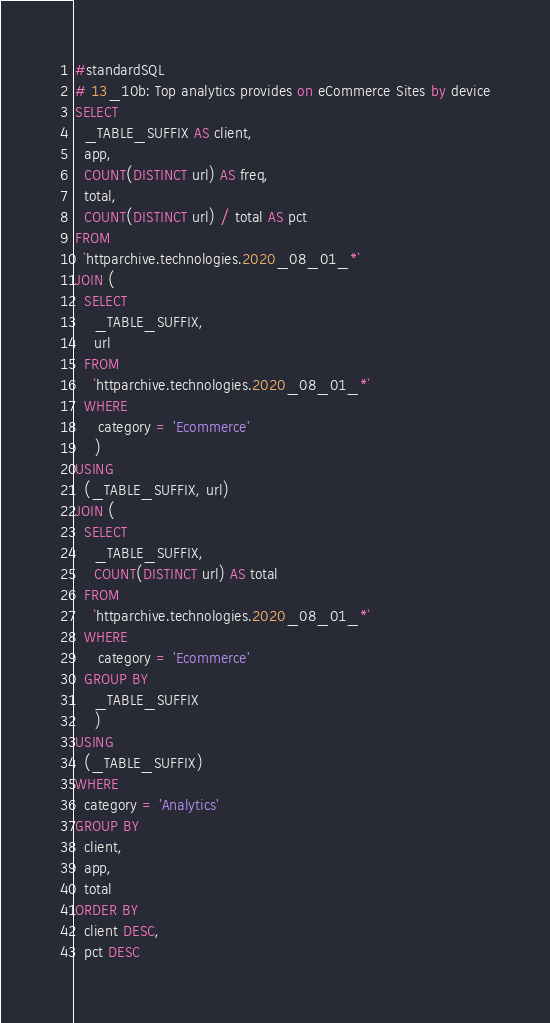<code> <loc_0><loc_0><loc_500><loc_500><_SQL_>#standardSQL
# 13_10b: Top analytics provides on eCommerce Sites by device
SELECT
  _TABLE_SUFFIX AS client,
  app,
  COUNT(DISTINCT url) AS freq,
  total,
  COUNT(DISTINCT url) / total AS pct
FROM
  `httparchive.technologies.2020_08_01_*`
JOIN (
  SELECT
    _TABLE_SUFFIX,
    url
  FROM
    `httparchive.technologies.2020_08_01_*`
  WHERE
     category = 'Ecommerce'
    )
USING
  (_TABLE_SUFFIX, url)
JOIN (
  SELECT
    _TABLE_SUFFIX,
    COUNT(DISTINCT url) AS total
  FROM
    `httparchive.technologies.2020_08_01_*`
  WHERE
     category = 'Ecommerce'
  GROUP BY
    _TABLE_SUFFIX
    )
USING
  (_TABLE_SUFFIX)
WHERE
  category = 'Analytics'
GROUP BY
  client,
  app,
  total
ORDER BY
  client DESC,
  pct DESC
</code> 